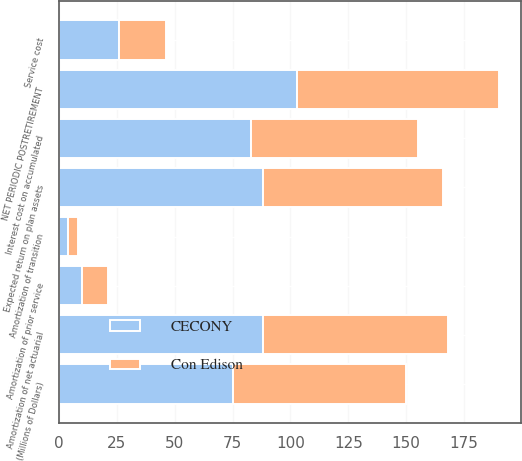Convert chart to OTSL. <chart><loc_0><loc_0><loc_500><loc_500><stacked_bar_chart><ecel><fcel>(Millions of Dollars)<fcel>Service cost<fcel>Interest cost on accumulated<fcel>Expected return on plan assets<fcel>Amortization of net actuarial<fcel>Amortization of prior service<fcel>Amortization of transition<fcel>NET PERIODIC POSTRETIREMENT<nl><fcel>CECONY<fcel>75<fcel>26<fcel>83<fcel>88<fcel>88<fcel>10<fcel>4<fcel>103<nl><fcel>Con Edison<fcel>75<fcel>20<fcel>72<fcel>78<fcel>80<fcel>11<fcel>4<fcel>87<nl></chart> 